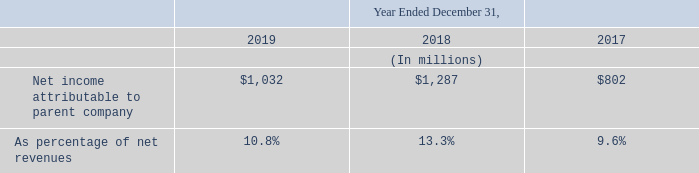For 2019, we reported a net income of $1,032 million, compared to a net income of $1,287 million and $802 million for 2018 and 2017, respectively.
The 2019 net income represented diluted earnings per share of $1.14 compared to $1.41 and $0.89 for 2018 and 2017, respectively.
How much net income represented diluted earnings per share in 2019? $1.14. How much net income represented diluted earnings per share in 2018? $1.41. How much net income represented diluted earnings per share in 2017? $0.89. What is the average net income attributable to parent company?
Answer scale should be: million. (1,032+1,287+802) / 3
Answer: 1040.33. What is the increase/ (decrease) in net income attributable to parent company from 2018 to 2019?
Answer scale should be: million. 1,032-1,287
Answer: -255. What is the increase/ (decrease) in net income attributable to parent company from 2017 to 2018?
Answer scale should be: million. 1,287-802 
Answer: 485. 